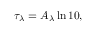<formula> <loc_0><loc_0><loc_500><loc_500>\tau _ { \lambda } = A _ { \lambda } \ln 1 0 ,</formula> 